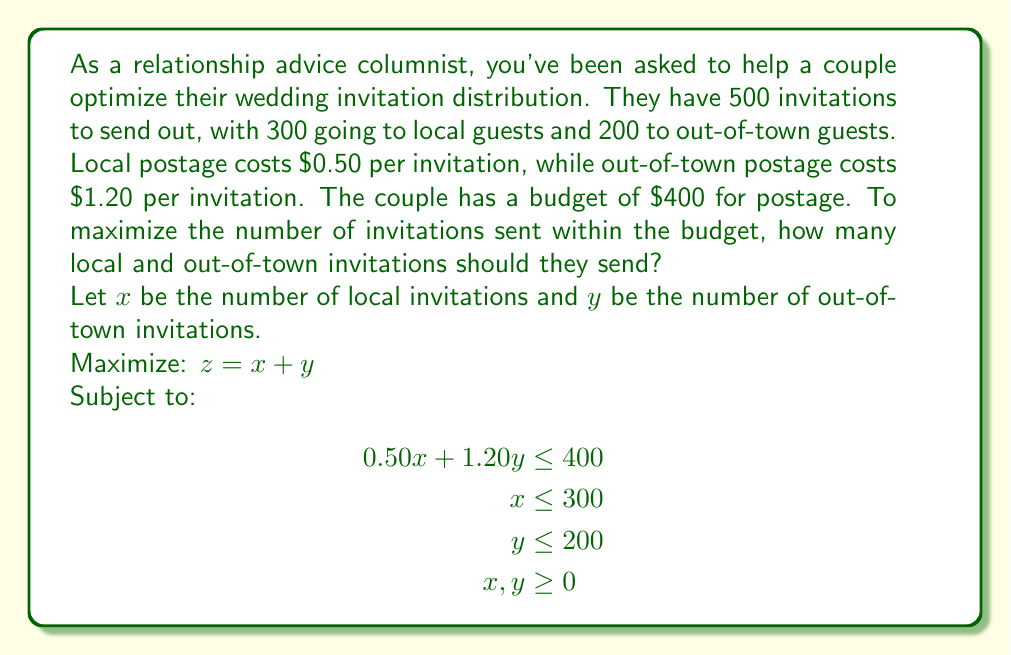Show me your answer to this math problem. To solve this linear programming problem, we'll use the graphical method:

1. Plot the constraints:
   - Budget constraint: $0.50x + 1.20y = 400$
   - Local invitation limit: $x = 300$
   - Out-of-town invitation limit: $y = 200$

2. Identify the feasible region:
   The feasible region is the area that satisfies all constraints.

3. Find the corner points of the feasible region:
   A (0, 0), B (300, 0), C (300, 166.67), D (240, 200)

4. Evaluate the objective function $z = x + y$ at each corner point:
   A: $z = 0 + 0 = 0$
   B: $z = 300 + 0 = 300$
   C: $z = 300 + 166.67 = 466.67$
   D: $z = 240 + 200 = 440$

5. The maximum value of $z$ occurs at point C (300, 166.67).

6. Since we can only send whole invitations, we round down to (300, 166).

Therefore, the couple should send 300 local invitations and 166 out-of-town invitations to maximize the total number of invitations within their budget.

[asy]
import geometry;

size(200);

// Define axes
xaxis("Local invitations (x)", 0, 350, Arrow);
yaxis("Out-of-town invitations (y)", 0, 250, Arrow);

// Plot constraints
draw((0,333.33)--(800,0), blue+dashed);
draw((300,0)--(300,250), red+dashed);
draw((0,200)--(350,200), green+dashed);

// Shade feasible region
fill((0,0)--(300,0)--(300,166.67)--(240,200)--(0,200)--cycle, lightgray);

// Label points
dot((300,166.67));
label("C (300, 166.67)", (300,166.67), E);

dot((240,200));
label("D (240, 200)", (240,200), N);

dot((300,0));
label("B (300, 0)", (300,0), S);

dot((0,0));
label("A (0, 0)", (0,0), SW);

// Legend
label("Budget constraint", (350,150), E, blue);
label("Local invitation limit", (300,250), N, red);
label("Out-of-town invitation limit", (150,220), N, green);
[/asy]
Answer: The couple should send 300 local invitations and 166 out-of-town invitations to maximize the total number of invitations within their budget. 